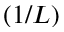<formula> <loc_0><loc_0><loc_500><loc_500>( 1 / L )</formula> 